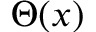Convert formula to latex. <formula><loc_0><loc_0><loc_500><loc_500>\Theta ( x )</formula> 